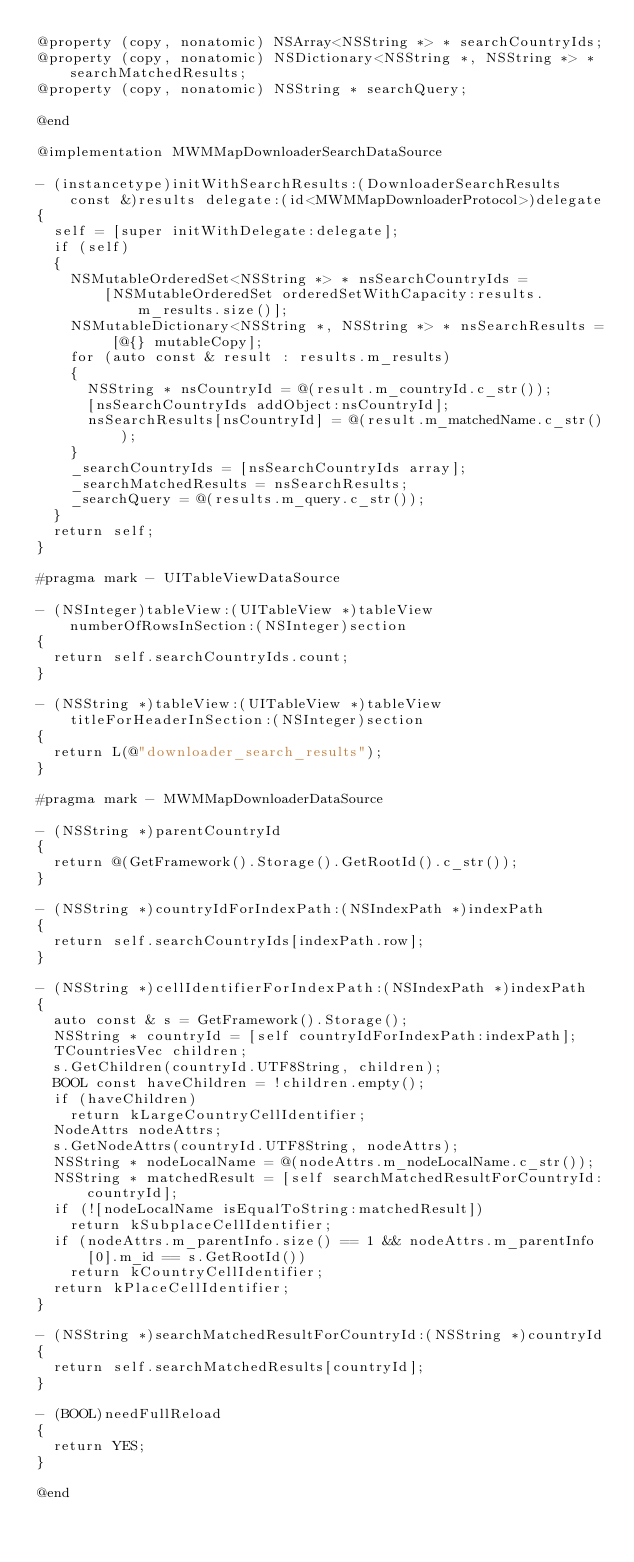Convert code to text. <code><loc_0><loc_0><loc_500><loc_500><_ObjectiveC_>@property (copy, nonatomic) NSArray<NSString *> * searchCountryIds;
@property (copy, nonatomic) NSDictionary<NSString *, NSString *> * searchMatchedResults;
@property (copy, nonatomic) NSString * searchQuery;

@end

@implementation MWMMapDownloaderSearchDataSource

- (instancetype)initWithSearchResults:(DownloaderSearchResults const &)results delegate:(id<MWMMapDownloaderProtocol>)delegate
{
  self = [super initWithDelegate:delegate];
  if (self)
  {
    NSMutableOrderedSet<NSString *> * nsSearchCountryIds =
        [NSMutableOrderedSet orderedSetWithCapacity:results.m_results.size()];
    NSMutableDictionary<NSString *, NSString *> * nsSearchResults = [@{} mutableCopy];
    for (auto const & result : results.m_results)
    {
      NSString * nsCountryId = @(result.m_countryId.c_str());
      [nsSearchCountryIds addObject:nsCountryId];
      nsSearchResults[nsCountryId] = @(result.m_matchedName.c_str());
    }
    _searchCountryIds = [nsSearchCountryIds array];
    _searchMatchedResults = nsSearchResults;
    _searchQuery = @(results.m_query.c_str());
  }
  return self;
}

#pragma mark - UITableViewDataSource

- (NSInteger)tableView:(UITableView *)tableView numberOfRowsInSection:(NSInteger)section
{
  return self.searchCountryIds.count;
}

- (NSString *)tableView:(UITableView *)tableView titleForHeaderInSection:(NSInteger)section
{
  return L(@"downloader_search_results");
}

#pragma mark - MWMMapDownloaderDataSource

- (NSString *)parentCountryId
{
  return @(GetFramework().Storage().GetRootId().c_str());
}

- (NSString *)countryIdForIndexPath:(NSIndexPath *)indexPath
{
  return self.searchCountryIds[indexPath.row];
}

- (NSString *)cellIdentifierForIndexPath:(NSIndexPath *)indexPath
{
  auto const & s = GetFramework().Storage();
  NSString * countryId = [self countryIdForIndexPath:indexPath];
  TCountriesVec children;
  s.GetChildren(countryId.UTF8String, children);
  BOOL const haveChildren = !children.empty();
  if (haveChildren)
    return kLargeCountryCellIdentifier;
  NodeAttrs nodeAttrs;
  s.GetNodeAttrs(countryId.UTF8String, nodeAttrs);
  NSString * nodeLocalName = @(nodeAttrs.m_nodeLocalName.c_str());
  NSString * matchedResult = [self searchMatchedResultForCountryId:countryId];
  if (![nodeLocalName isEqualToString:matchedResult])
    return kSubplaceCellIdentifier;
  if (nodeAttrs.m_parentInfo.size() == 1 && nodeAttrs.m_parentInfo[0].m_id == s.GetRootId())
    return kCountryCellIdentifier;
  return kPlaceCellIdentifier;
}

- (NSString *)searchMatchedResultForCountryId:(NSString *)countryId
{
  return self.searchMatchedResults[countryId];
}

- (BOOL)needFullReload
{
  return YES;
}

@end
</code> 